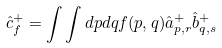<formula> <loc_0><loc_0><loc_500><loc_500>\hat { c } _ { f } ^ { + } = \int \int d p d q f ( p , q ) \hat { a } _ { p , r } ^ { + } \hat { b } _ { q , s } ^ { + }</formula> 